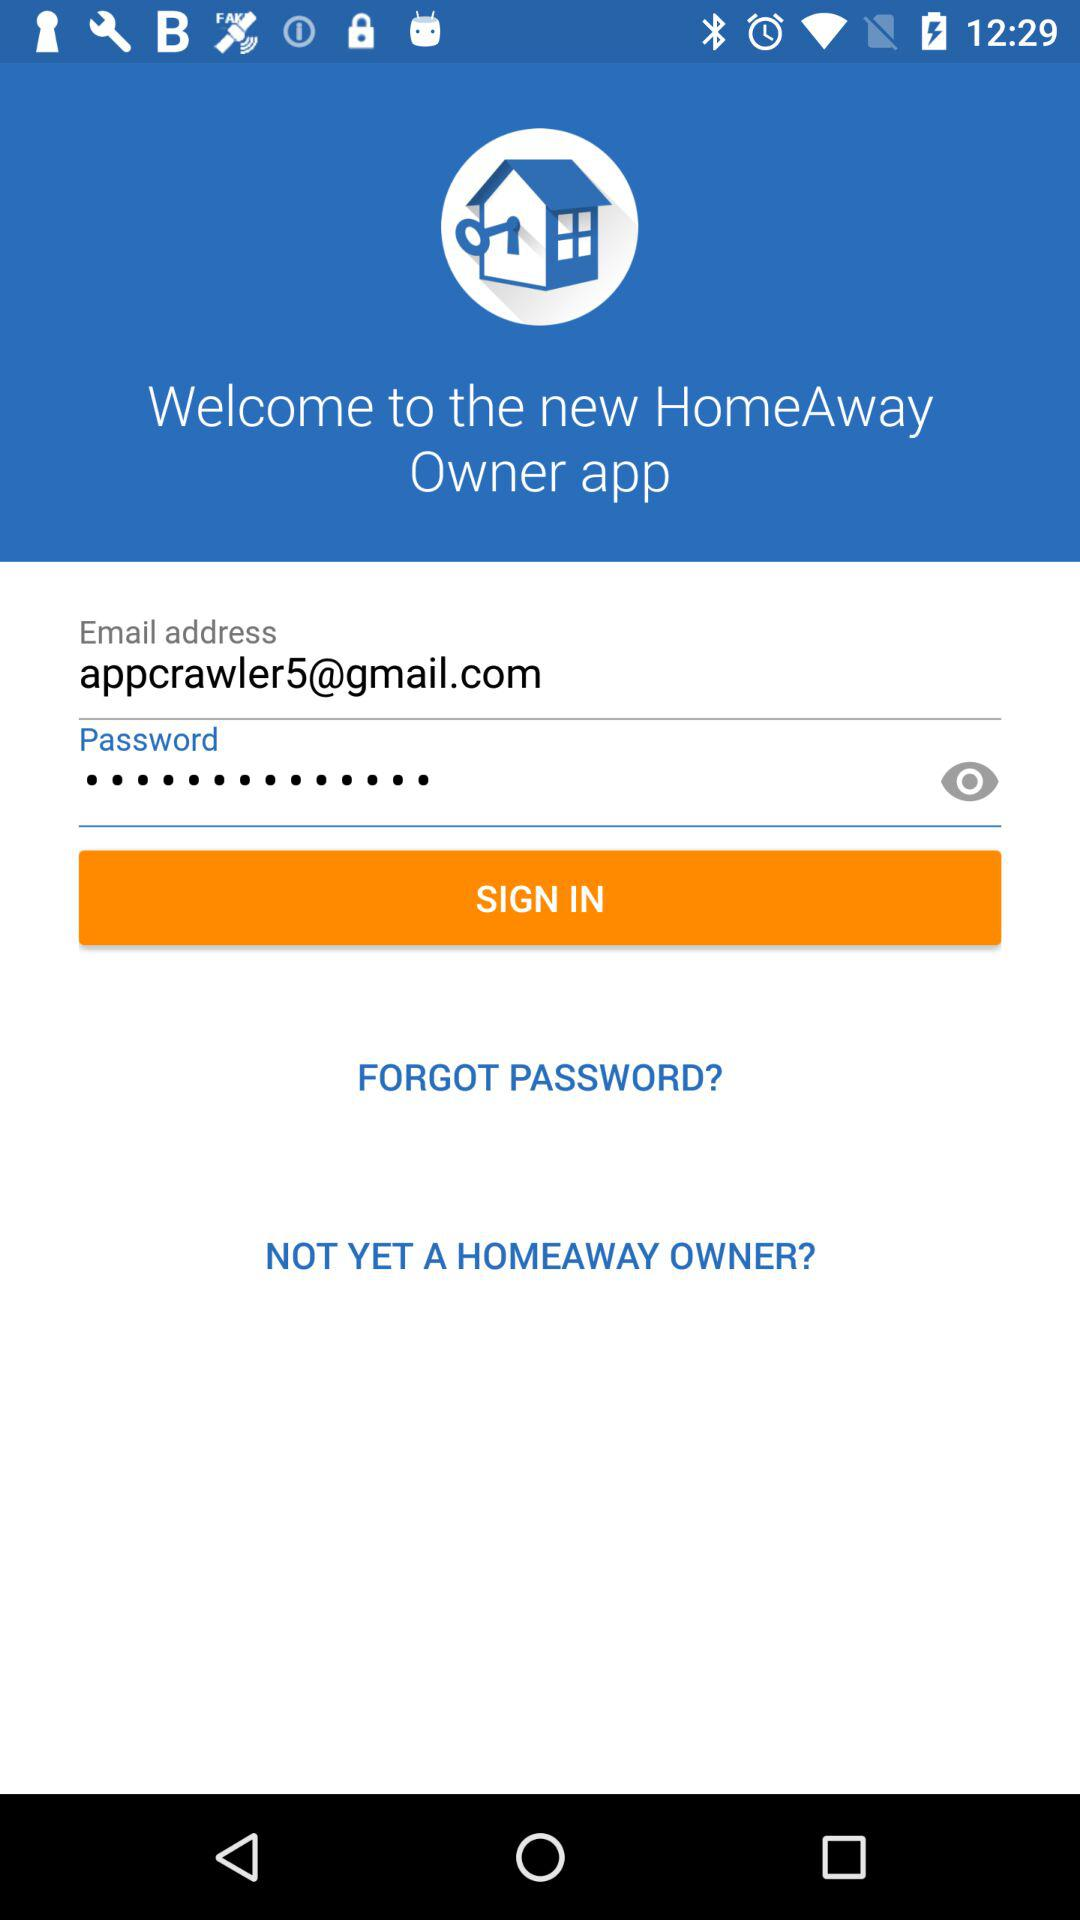What is the email address? The email address is appcrawler5@gmail.com. 